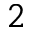Convert formula to latex. <formula><loc_0><loc_0><loc_500><loc_500>^ { 2 }</formula> 